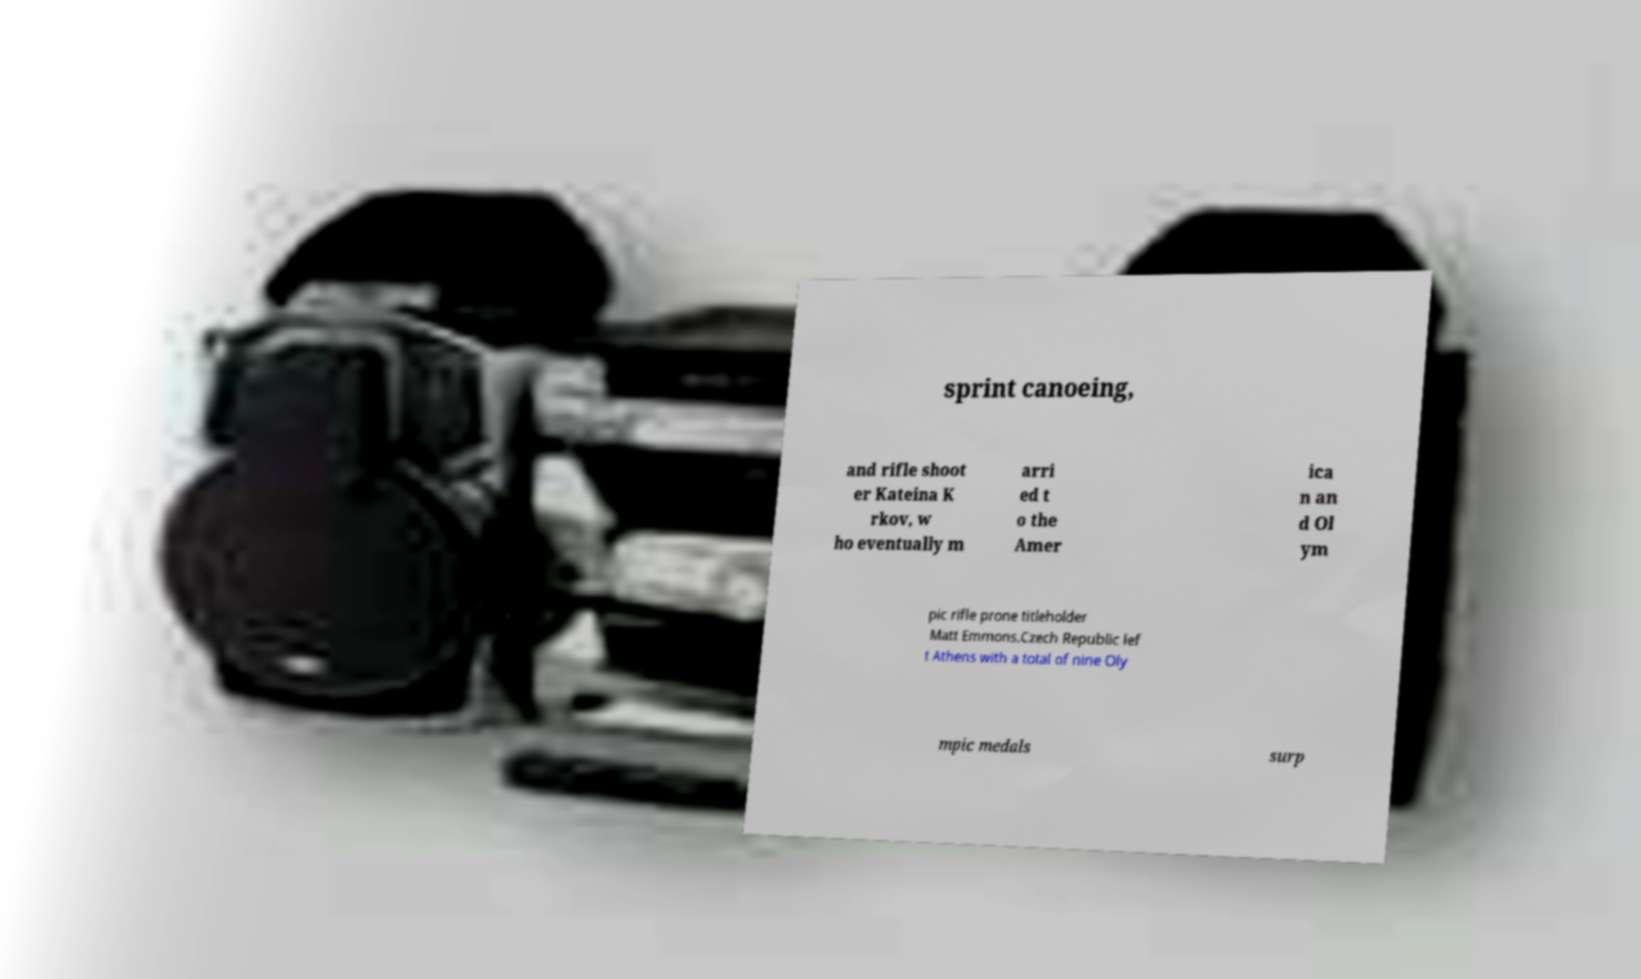There's text embedded in this image that I need extracted. Can you transcribe it verbatim? sprint canoeing, and rifle shoot er Kateina K rkov, w ho eventually m arri ed t o the Amer ica n an d Ol ym pic rifle prone titleholder Matt Emmons.Czech Republic lef t Athens with a total of nine Oly mpic medals surp 